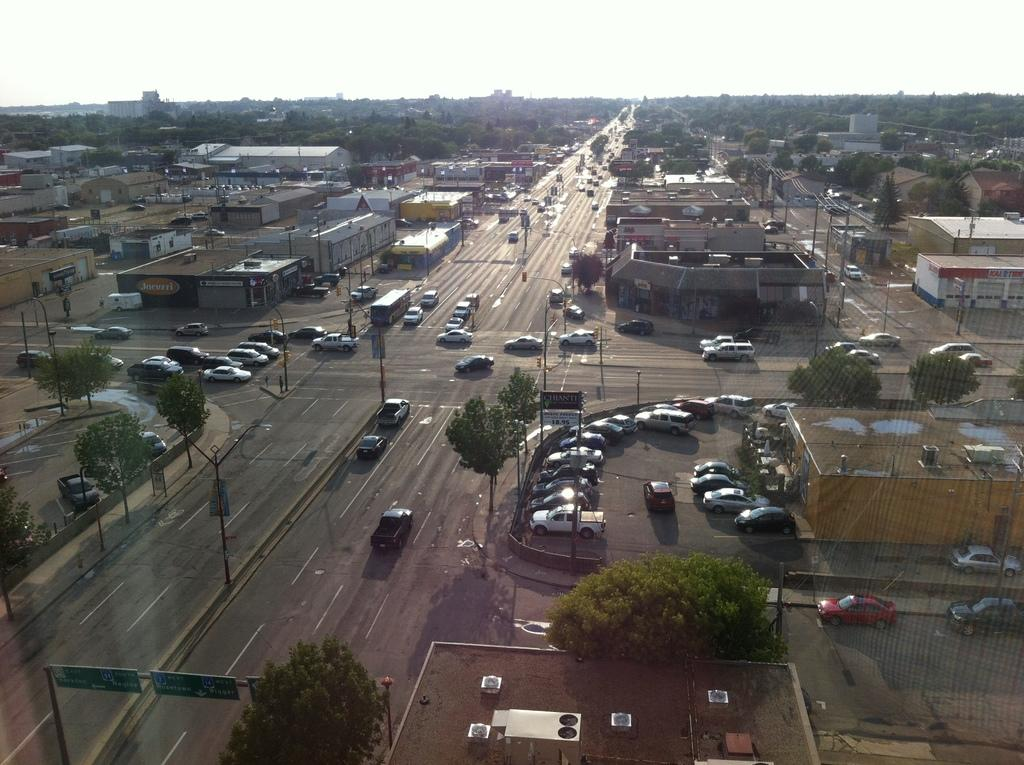What type of infrastructure can be seen in the image? There are roads in the image. What is happening on the roads? Cars and other vehicles are moving on the roads. What type of natural elements are visible in the image? There are trees visible in the image. What type of man-made structures can be seen in the image? There are buildings in the image. What can be seen in the background of the image? The sky is visible in the background of the image. What type of guitar can be seen hanging on the wall in the image? There is no guitar or wall present in the image; it features roads, cars, trees, buildings, and the sky. What time of day is it in the image, considering it's an afternoon scene? The time of day cannot be determined from the image, as there are no specific indicators of time. 